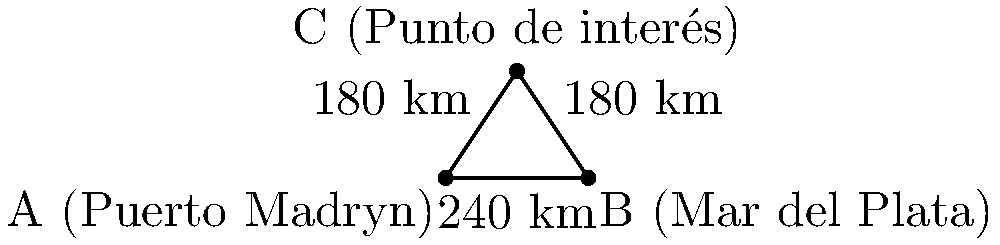Un velero argentino parte de Puerto Madryn (A) y debe llegar a Mar del Plata (B), pasando por un punto de interés (C) en el camino. La distancia entre Puerto Madryn y Mar del Plata es de 240 km, y ambas ciudades están a 180 km del punto de interés. Si el velero navega a una velocidad constante de 20 km/h, ¿cuánto tiempo adicional (en horas) tomará el viaje si pasa por el punto C en comparación con navegar directamente de A a B? Para resolver este problema, seguiremos estos pasos:

1) Primero, calculemos la distancia total recorrida pasando por C:
   Distancia A a C + Distancia C a B = 180 km + 180 km = 360 km

2) Ahora, calculemos el tiempo que toma este viaje:
   Tiempo = Distancia / Velocidad
   Tiempo = 360 km / 20 km/h = 18 horas

3) Luego, calculemos el tiempo que tomaría ir directamente de A a B:
   Tiempo directo = 240 km / 20 km/h = 12 horas

4) La diferencia de tiempo es:
   Tiempo adicional = 18 horas - 12 horas = 6 horas

Por lo tanto, el viaje pasando por el punto de interés C tomará 6 horas adicionales.
Answer: 6 horas 